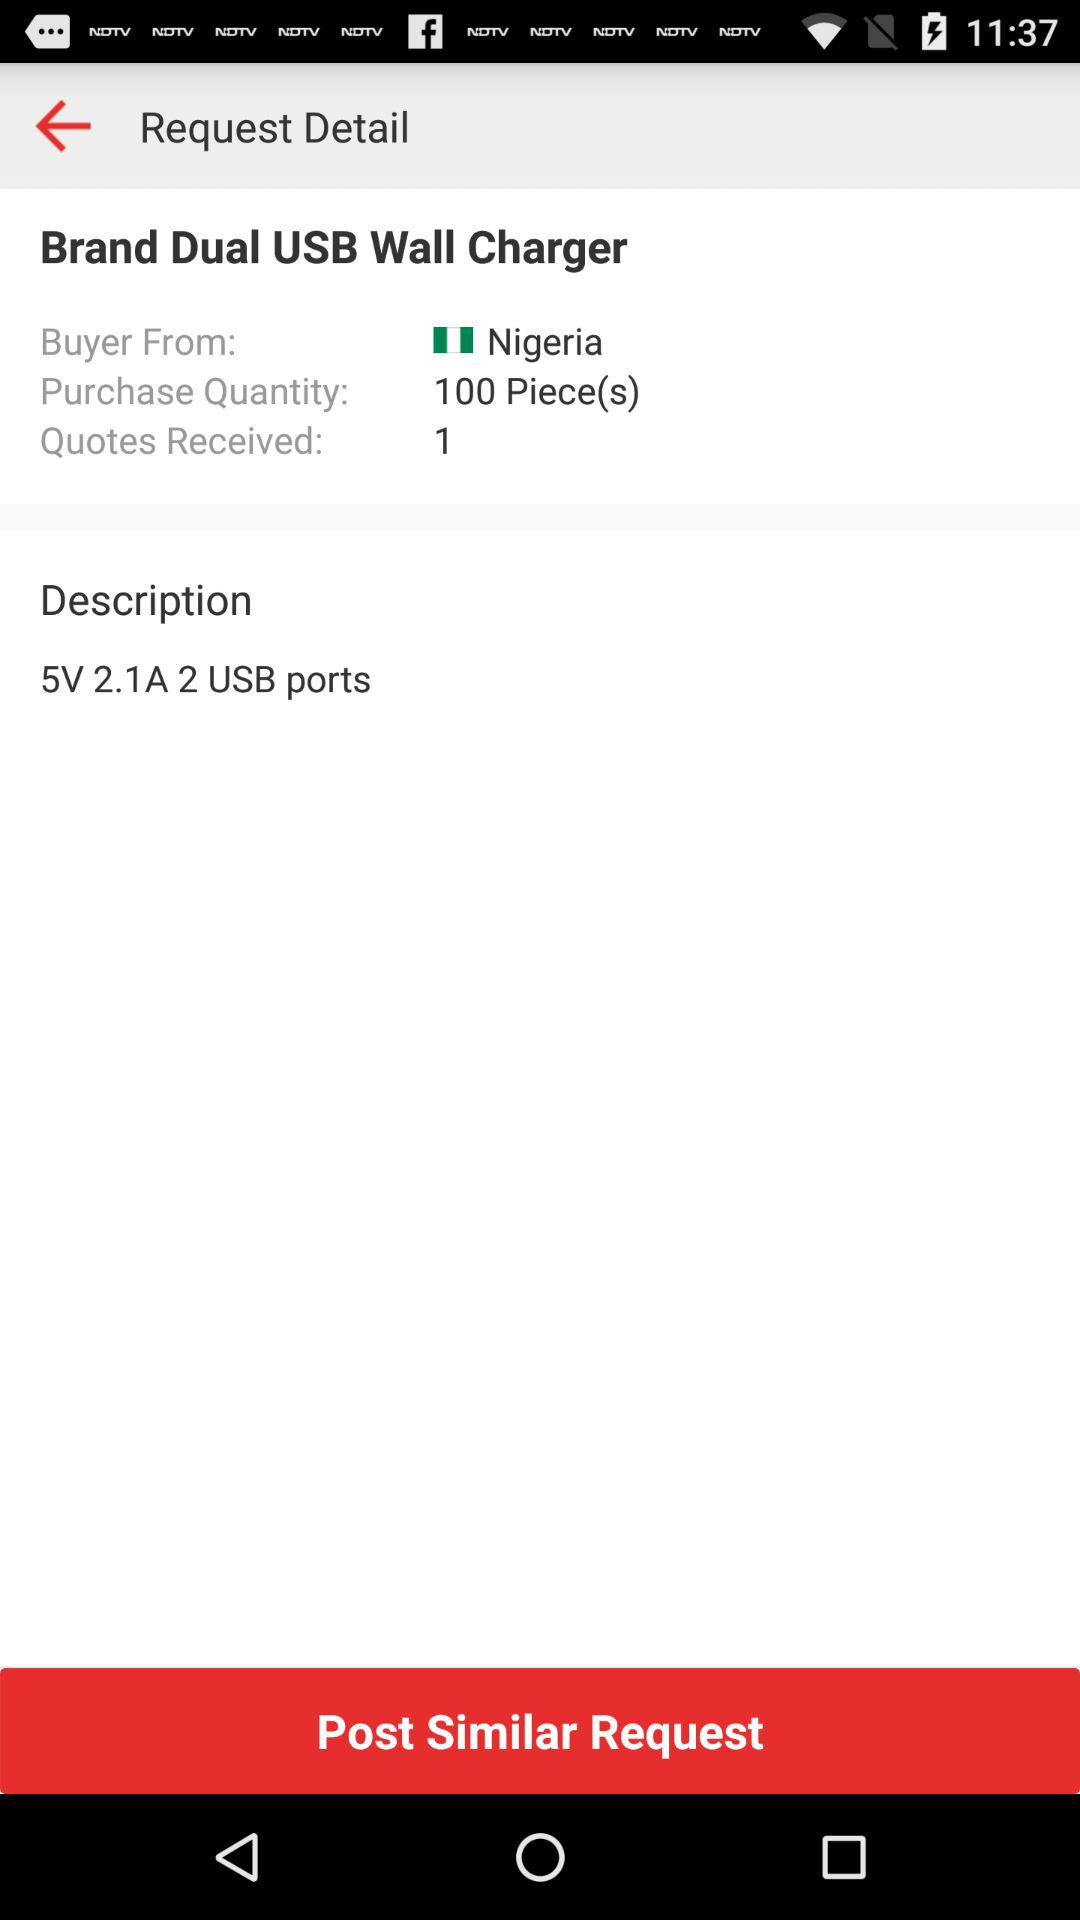How many quotes have been received for this request?
Answer the question using a single word or phrase. 1 